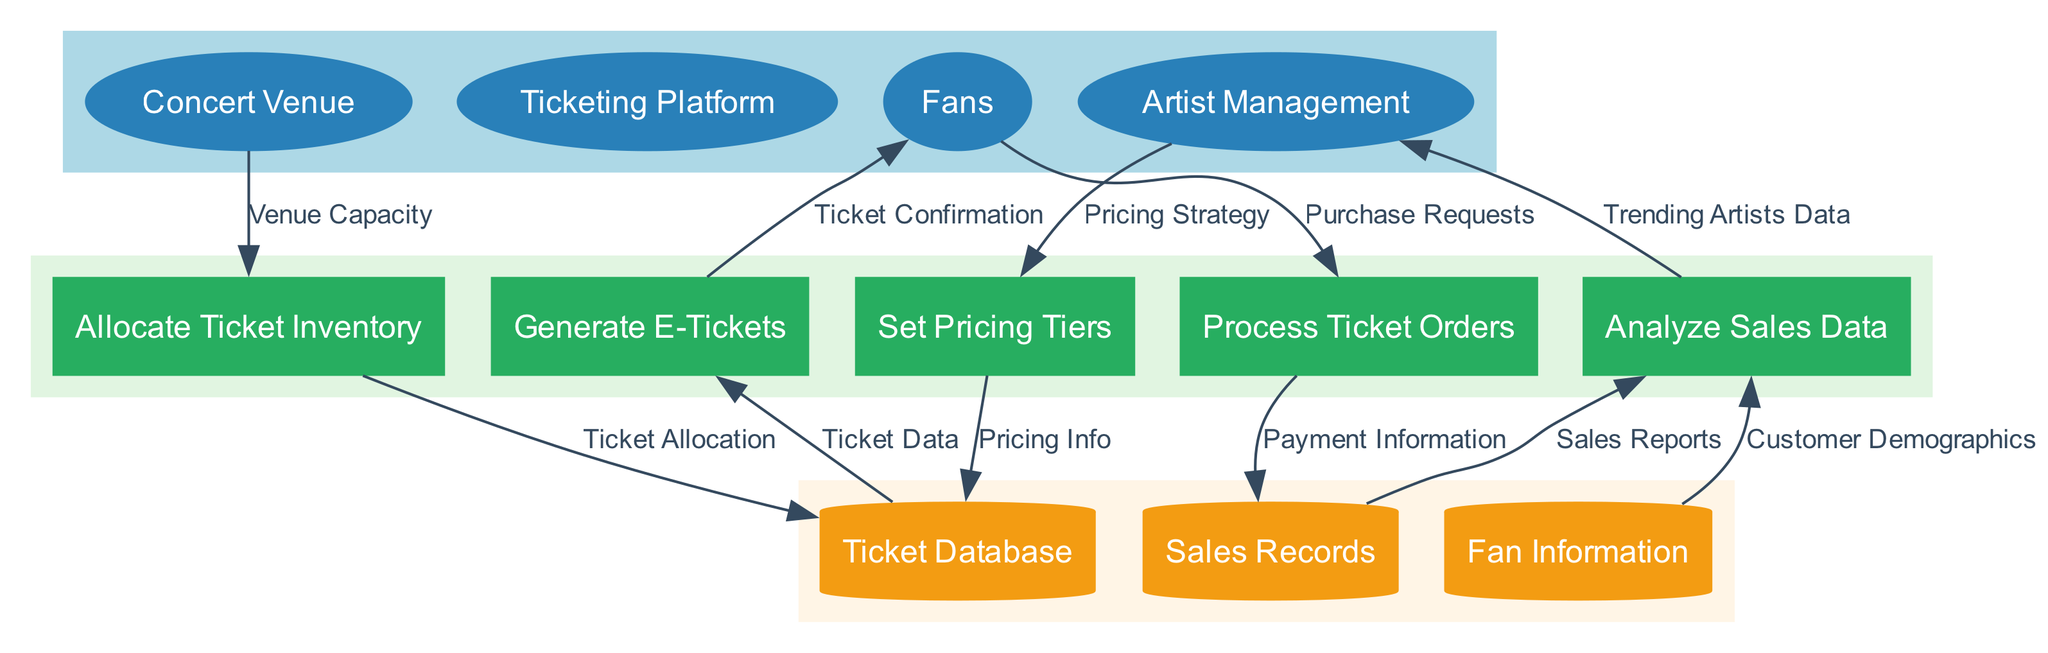What external entity is responsible for providing venue capacity? The diagram shows that the "Concert Venue" external entity is connected to the "Allocate Ticket Inventory" process with the data flow labeled "Venue Capacity," indicating that this entity provides that information.
Answer: Concert Venue How many processes are depicted in the diagram? The diagram lists five processes: "Allocate Ticket Inventory," "Set Pricing Tiers," "Process Ticket Orders," "Generate E-Tickets," and "Analyze Sales Data." Therefore, there are five processes in total.
Answer: 5 Which process generates ticket confirmations for fans? The "Generate E-Tickets" process is connected to the "Fans" external entity with the data flow labeled "Ticket Confirmation," indicating that this process is responsible for generating confirmations for ticket purchases.
Answer: Generate E-Tickets What type of data store holds fan information? The "Fan Information" data store is categorized as a data store in the diagram and is specifically labeled as such.
Answer: Fan Information Which external entity influences the pricing strategy? The "Artist Management" entity is connected to the "Set Pricing Tiers" process with the data flow labeled "Pricing Strategy," indicating that this external entity has influence over ticket pricing.
Answer: Artist Management What data flow connects the ticket database to the process that generates e-tickets? The "Ticket Data" data flow connects the "Ticket Database" to the "Generate E-Tickets" process, indicating that this flow provides necessary information for ticket generation.
Answer: Ticket Data In which process is sales data analyzed? The diagram shows that the "Analyze Sales Data" process is specifically designated for analyzing both sales reports and customer demographics, as indicated by its connections to the corresponding data stores.
Answer: Analyze Sales Data What type of information is stored in the sales records data store? The sales records data store is indicated in the diagram to hold sales reports, which reflect ticket sales data and transactions.
Answer: Sales Reports Which two processes directly involve fans? The "Process Ticket Orders" and "Generate E-Tickets" processes are both directly connected to the "Fans" external entity, indicating their involvement in the ticket sales process.
Answer: Process Ticket Orders, Generate E-Tickets What data flow represents payment information? The "Payment Information" data flow represents the information related to ticket purchases that is passed from the "Process Ticket Orders" process to the "Sales Records" data store.
Answer: Payment Information 